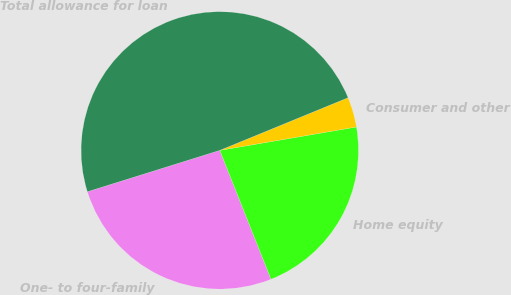Convert chart to OTSL. <chart><loc_0><loc_0><loc_500><loc_500><pie_chart><fcel>One- to four-family<fcel>Home equity<fcel>Consumer and other<fcel>Total allowance for loan<nl><fcel>26.2%<fcel>21.68%<fcel>3.5%<fcel>48.62%<nl></chart> 